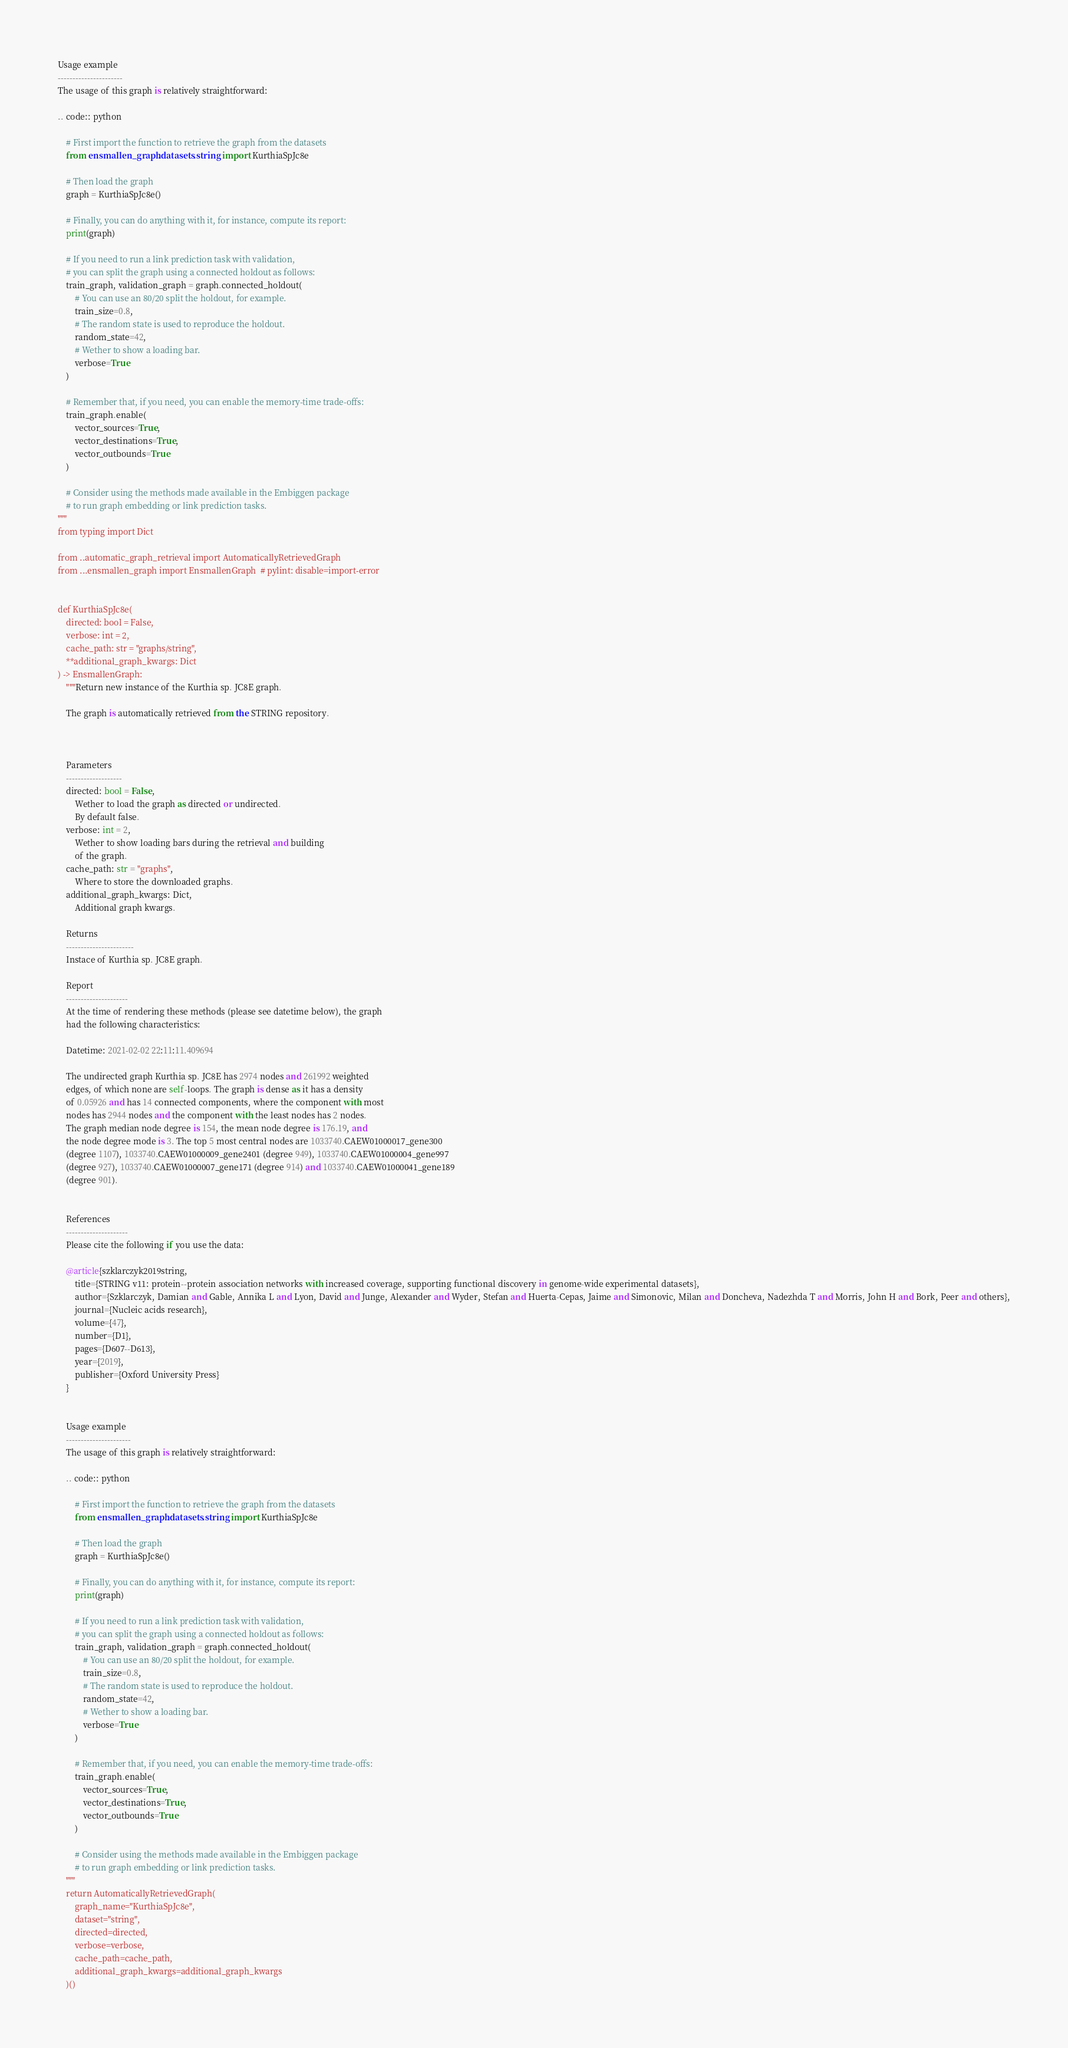Convert code to text. <code><loc_0><loc_0><loc_500><loc_500><_Python_>

Usage example
----------------------
The usage of this graph is relatively straightforward:

.. code:: python

    # First import the function to retrieve the graph from the datasets
    from ensmallen_graph.datasets.string import KurthiaSpJc8e

    # Then load the graph
    graph = KurthiaSpJc8e()

    # Finally, you can do anything with it, for instance, compute its report:
    print(graph)

    # If you need to run a link prediction task with validation,
    # you can split the graph using a connected holdout as follows:
    train_graph, validation_graph = graph.connected_holdout(
        # You can use an 80/20 split the holdout, for example.
        train_size=0.8,
        # The random state is used to reproduce the holdout.
        random_state=42,
        # Wether to show a loading bar.
        verbose=True
    )

    # Remember that, if you need, you can enable the memory-time trade-offs:
    train_graph.enable(
        vector_sources=True,
        vector_destinations=True,
        vector_outbounds=True
    )

    # Consider using the methods made available in the Embiggen package
    # to run graph embedding or link prediction tasks.
"""
from typing import Dict

from ..automatic_graph_retrieval import AutomaticallyRetrievedGraph
from ...ensmallen_graph import EnsmallenGraph  # pylint: disable=import-error


def KurthiaSpJc8e(
    directed: bool = False,
    verbose: int = 2,
    cache_path: str = "graphs/string",
    **additional_graph_kwargs: Dict
) -> EnsmallenGraph:
    """Return new instance of the Kurthia sp. JC8E graph.

    The graph is automatically retrieved from the STRING repository. 

	

    Parameters
    -------------------
    directed: bool = False,
        Wether to load the graph as directed or undirected.
        By default false.
    verbose: int = 2,
        Wether to show loading bars during the retrieval and building
        of the graph.
    cache_path: str = "graphs",
        Where to store the downloaded graphs.
    additional_graph_kwargs: Dict,
        Additional graph kwargs.

    Returns
    -----------------------
    Instace of Kurthia sp. JC8E graph.

	Report
	---------------------
	At the time of rendering these methods (please see datetime below), the graph
	had the following characteristics:
	
	Datetime: 2021-02-02 22:11:11.409694
	
	The undirected graph Kurthia sp. JC8E has 2974 nodes and 261992 weighted
	edges, of which none are self-loops. The graph is dense as it has a density
	of 0.05926 and has 14 connected components, where the component with most
	nodes has 2944 nodes and the component with the least nodes has 2 nodes.
	The graph median node degree is 154, the mean node degree is 176.19, and
	the node degree mode is 3. The top 5 most central nodes are 1033740.CAEW01000017_gene300
	(degree 1107), 1033740.CAEW01000009_gene2401 (degree 949), 1033740.CAEW01000004_gene997
	(degree 927), 1033740.CAEW01000007_gene171 (degree 914) and 1033740.CAEW01000041_gene189
	(degree 901).
	

	References
	---------------------
	Please cite the following if you use the data:
	
	@article{szklarczyk2019string,
	    title={STRING v11: protein--protein association networks with increased coverage, supporting functional discovery in genome-wide experimental datasets},
	    author={Szklarczyk, Damian and Gable, Annika L and Lyon, David and Junge, Alexander and Wyder, Stefan and Huerta-Cepas, Jaime and Simonovic, Milan and Doncheva, Nadezhda T and Morris, John H and Bork, Peer and others},
	    journal={Nucleic acids research},
	    volume={47},
	    number={D1},
	    pages={D607--D613},
	    year={2019},
	    publisher={Oxford University Press}
	}
	

	Usage example
	----------------------
	The usage of this graph is relatively straightforward:
	
	.. code:: python
	
	    # First import the function to retrieve the graph from the datasets
	    from ensmallen_graph.datasets.string import KurthiaSpJc8e
	
	    # Then load the graph
	    graph = KurthiaSpJc8e()
	
	    # Finally, you can do anything with it, for instance, compute its report:
	    print(graph)
	
	    # If you need to run a link prediction task with validation,
	    # you can split the graph using a connected holdout as follows:
	    train_graph, validation_graph = graph.connected_holdout(
	        # You can use an 80/20 split the holdout, for example.
	        train_size=0.8,
	        # The random state is used to reproduce the holdout.
	        random_state=42,
	        # Wether to show a loading bar.
	        verbose=True
	    )
	
	    # Remember that, if you need, you can enable the memory-time trade-offs:
	    train_graph.enable(
	        vector_sources=True,
	        vector_destinations=True,
	        vector_outbounds=True
	    )
	
	    # Consider using the methods made available in the Embiggen package
	    # to run graph embedding or link prediction tasks.
    """
    return AutomaticallyRetrievedGraph(
        graph_name="KurthiaSpJc8e",
        dataset="string",
        directed=directed,
        verbose=verbose,
        cache_path=cache_path,
        additional_graph_kwargs=additional_graph_kwargs
    )()
</code> 